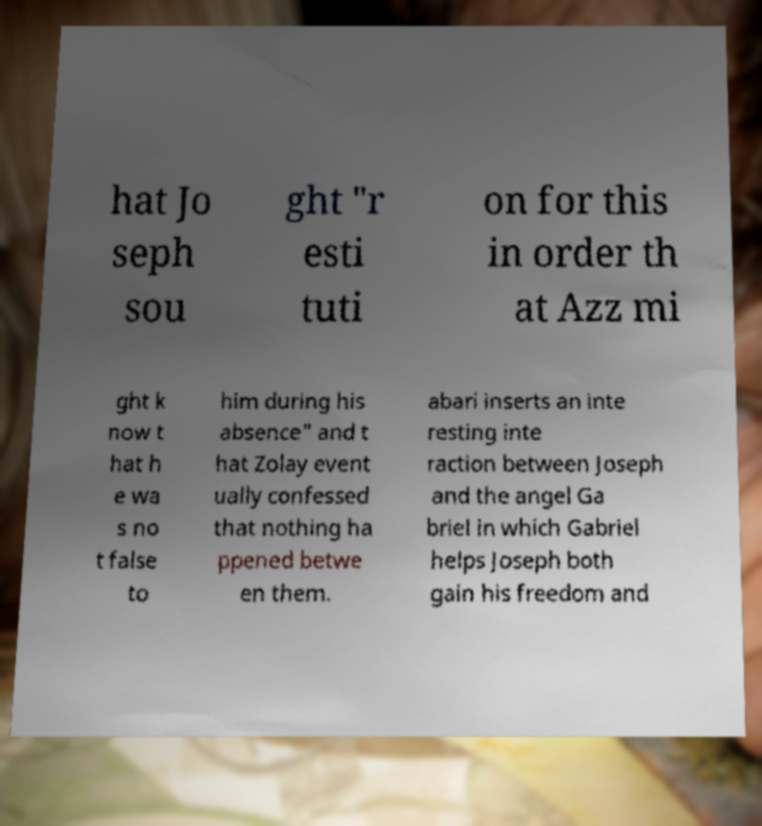Could you assist in decoding the text presented in this image and type it out clearly? hat Jo seph sou ght "r esti tuti on for this in order th at Azz mi ght k now t hat h e wa s no t false to him during his absence" and t hat Zolay event ually confessed that nothing ha ppened betwe en them. abari inserts an inte resting inte raction between Joseph and the angel Ga briel in which Gabriel helps Joseph both gain his freedom and 